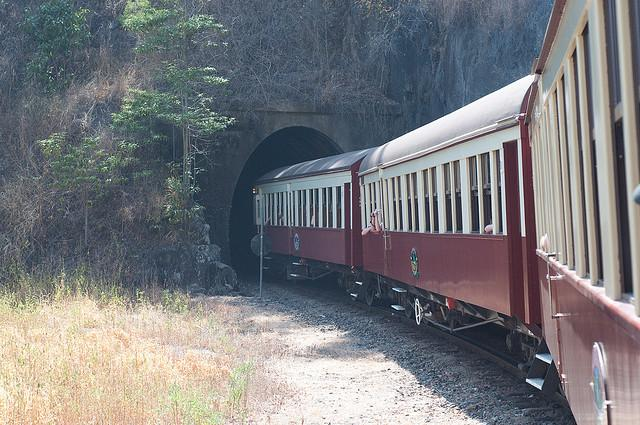If the train continues forward what will make it go out of sight first? Please explain your reasoning. tunnel. Even though the train is still close, when it goes inside this it can't be seen 